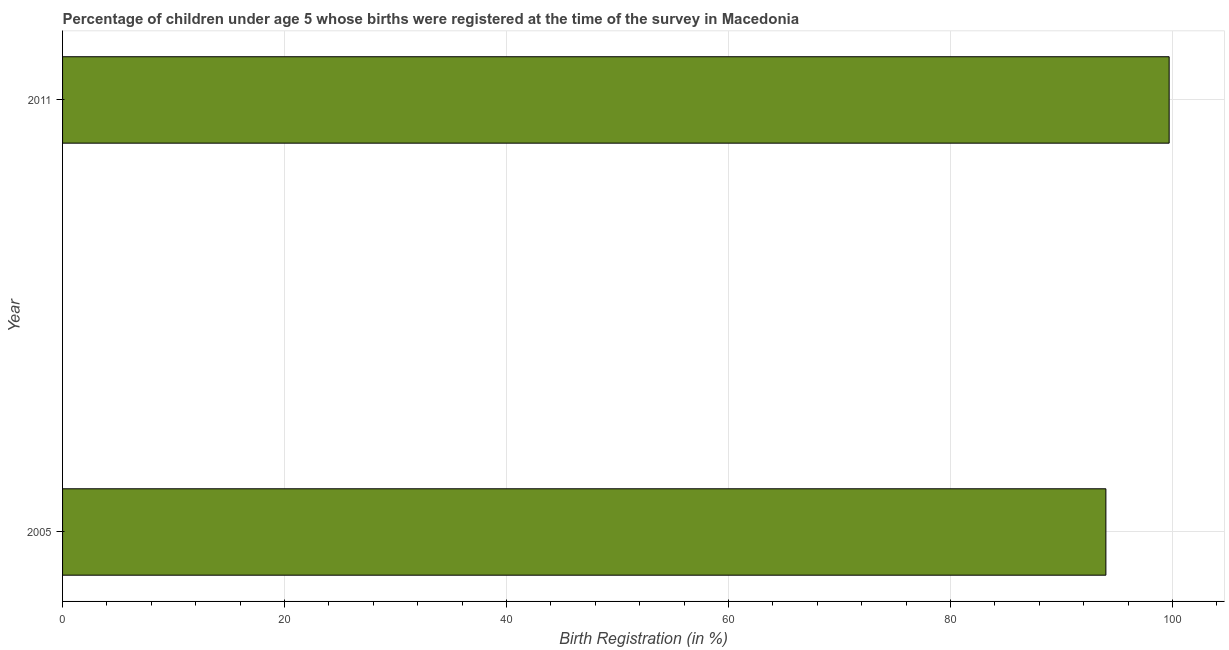Does the graph contain any zero values?
Give a very brief answer. No. Does the graph contain grids?
Your response must be concise. Yes. What is the title of the graph?
Keep it short and to the point. Percentage of children under age 5 whose births were registered at the time of the survey in Macedonia. What is the label or title of the X-axis?
Ensure brevity in your answer.  Birth Registration (in %). What is the label or title of the Y-axis?
Make the answer very short. Year. What is the birth registration in 2011?
Your response must be concise. 99.7. Across all years, what is the maximum birth registration?
Your answer should be very brief. 99.7. Across all years, what is the minimum birth registration?
Keep it short and to the point. 94. What is the sum of the birth registration?
Offer a very short reply. 193.7. What is the difference between the birth registration in 2005 and 2011?
Keep it short and to the point. -5.7. What is the average birth registration per year?
Your answer should be compact. 96.85. What is the median birth registration?
Give a very brief answer. 96.85. What is the ratio of the birth registration in 2005 to that in 2011?
Offer a very short reply. 0.94. Is the birth registration in 2005 less than that in 2011?
Offer a very short reply. Yes. Are all the bars in the graph horizontal?
Your answer should be compact. Yes. How many years are there in the graph?
Your answer should be compact. 2. What is the difference between two consecutive major ticks on the X-axis?
Your answer should be compact. 20. Are the values on the major ticks of X-axis written in scientific E-notation?
Make the answer very short. No. What is the Birth Registration (in %) in 2005?
Provide a succinct answer. 94. What is the Birth Registration (in %) in 2011?
Ensure brevity in your answer.  99.7. What is the ratio of the Birth Registration (in %) in 2005 to that in 2011?
Make the answer very short. 0.94. 